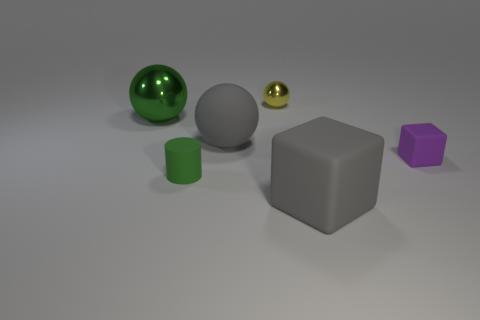Subtract all rubber spheres. How many spheres are left? 2 Subtract 1 spheres. How many spheres are left? 2 Add 3 tiny cyan spheres. How many objects exist? 9 Subtract all cubes. How many objects are left? 4 Subtract all small yellow metallic objects. Subtract all gray things. How many objects are left? 3 Add 2 small purple rubber objects. How many small purple rubber objects are left? 3 Add 1 big yellow shiny blocks. How many big yellow shiny blocks exist? 1 Subtract 1 yellow spheres. How many objects are left? 5 